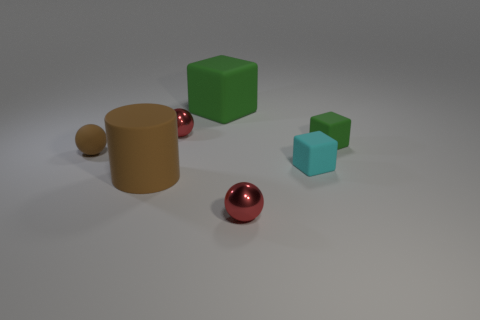What number of other things are there of the same color as the rubber cylinder?
Your answer should be very brief. 1. Is the shape of the brown matte thing right of the brown matte ball the same as  the small cyan matte thing?
Provide a short and direct response. No. The other tiny object that is the same shape as the small green rubber thing is what color?
Provide a succinct answer. Cyan. There is another green thing that is the same shape as the tiny green matte thing; what is its size?
Give a very brief answer. Large. There is a object that is to the right of the big brown matte object and in front of the small cyan cube; what is its material?
Your response must be concise. Metal. There is a sphere that is left of the brown cylinder; is it the same color as the big matte cylinder?
Your answer should be very brief. Yes. Is the color of the big cylinder the same as the thing to the left of the large brown rubber object?
Ensure brevity in your answer.  Yes. There is a big rubber cube; are there any brown things on the left side of it?
Offer a terse response. Yes. Are the tiny green object and the brown ball made of the same material?
Provide a succinct answer. Yes. There is a green block that is the same size as the cyan matte object; what is it made of?
Make the answer very short. Rubber. 